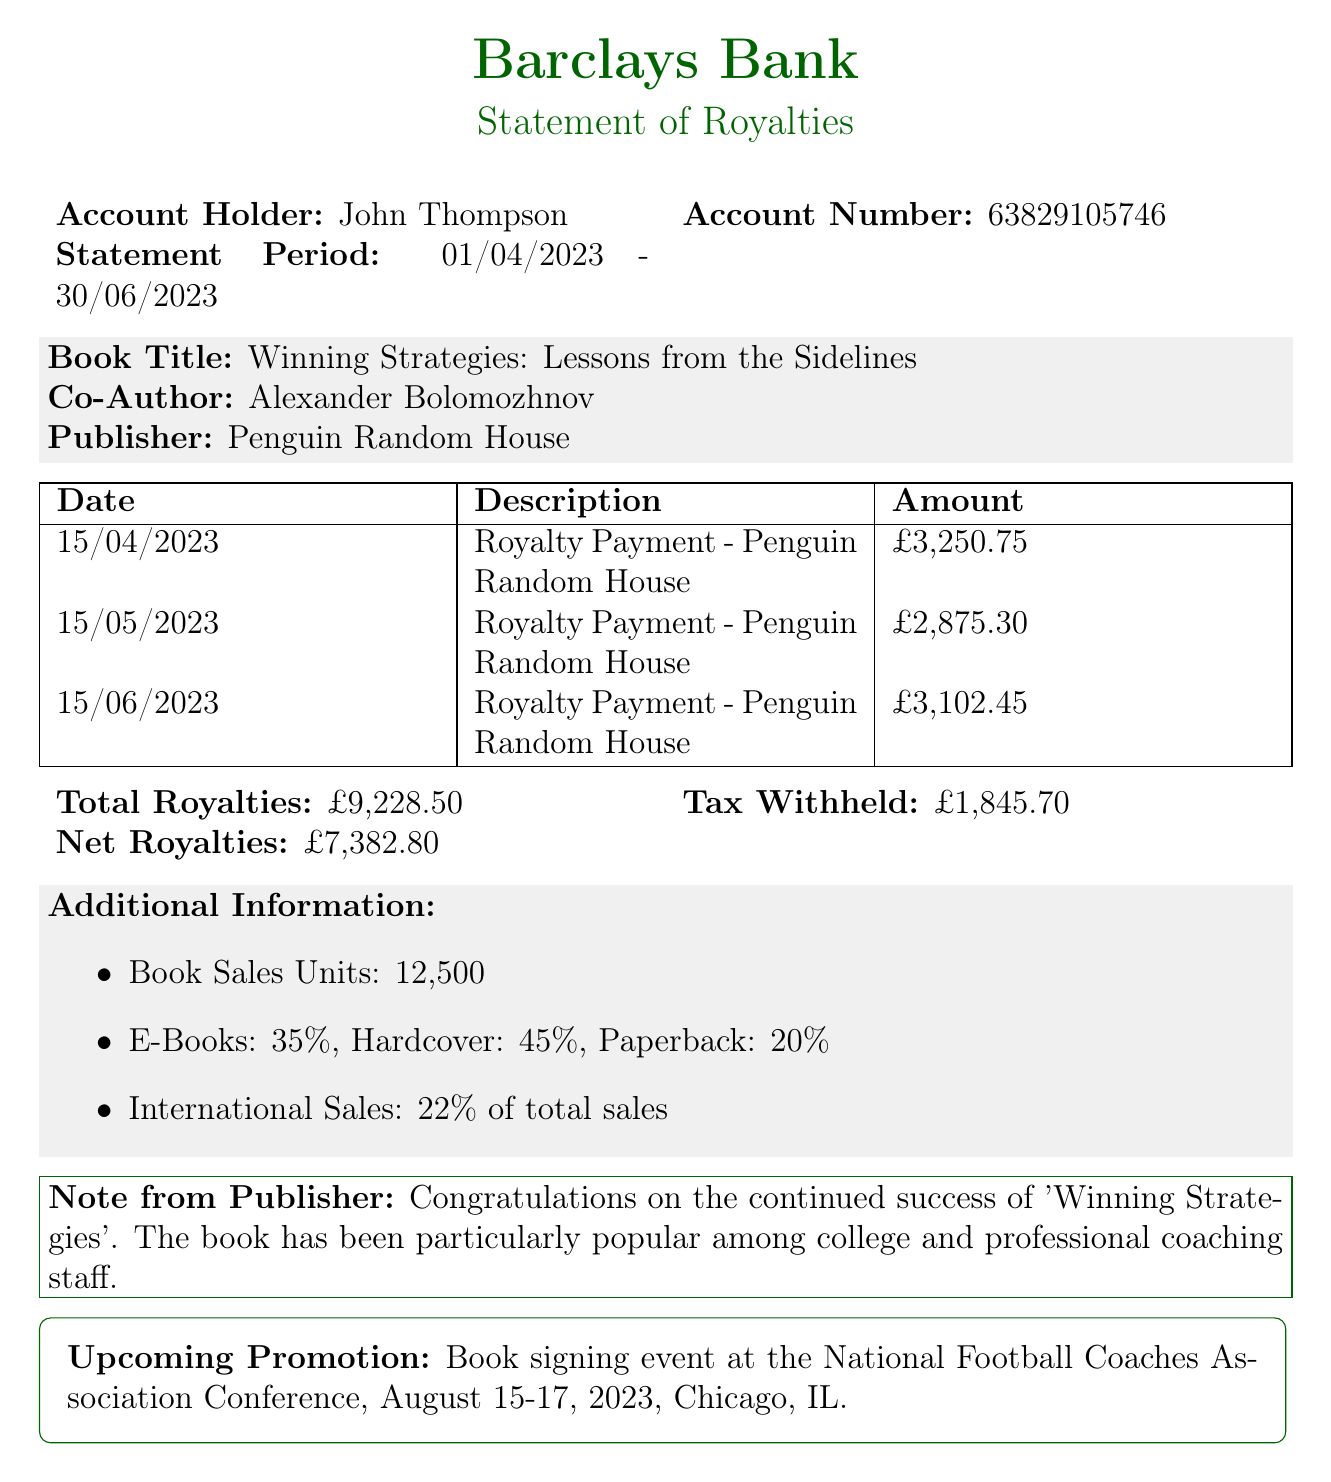What is the name of the bank? The bank is mentioned at the top of the document as Barclays Bank.
Answer: Barclays Bank Who is the account holder? The account holder's name is specified in the document as John Thompson.
Answer: John Thompson What is the statement period? The statement period indicates the time frame for the transactions, which is from 01/04/2023 to 30/06/2023.
Answer: 01/04/2023 - 30/06/2023 What is the total royalties received? The total royalties figure is explicitly stated in the document as £9,228.50.
Answer: £9,228.50 How much tax was withheld? The document provides the tax withheld amount as £1,845.70.
Answer: £1,845.70 What was the net royalty amount? The net royalties calculation is highlighted in the document as £7,382.80.
Answer: £7,382.80 What is the title of the book co-authored? The title of the book is clearly stated as Winning Strategies: Lessons from the Sidelines.
Answer: Winning Strategies: Lessons from the Sidelines When is the upcoming promotion event? The upcoming promotion event is scheduled for August 15-17, 2023, as specified in the document.
Answer: August 15-17, 2023 How many copies of the book were sold? The number of book sales units provided in the document is 12,500.
Answer: 12,500 